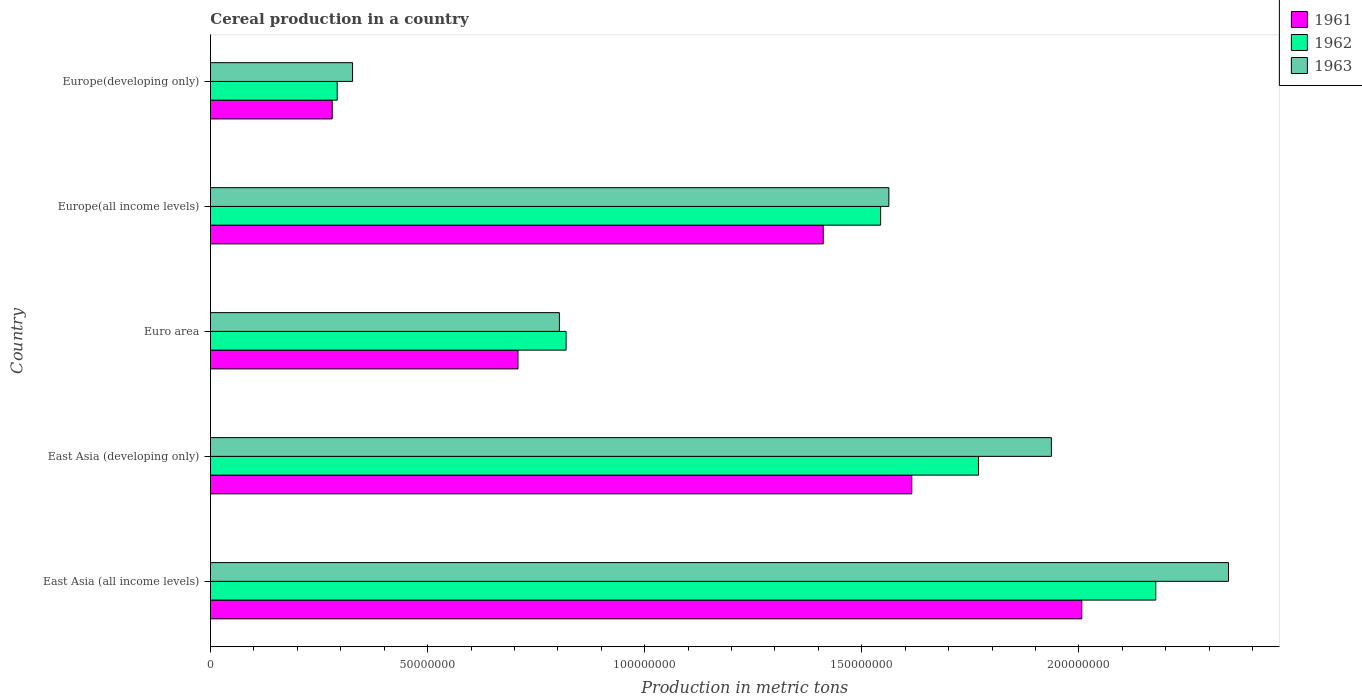How many different coloured bars are there?
Offer a very short reply. 3. How many groups of bars are there?
Keep it short and to the point. 5. Are the number of bars per tick equal to the number of legend labels?
Provide a succinct answer. Yes. Are the number of bars on each tick of the Y-axis equal?
Offer a very short reply. Yes. What is the label of the 1st group of bars from the top?
Provide a short and direct response. Europe(developing only). What is the total cereal production in 1962 in Europe(developing only)?
Keep it short and to the point. 2.92e+07. Across all countries, what is the maximum total cereal production in 1961?
Your answer should be very brief. 2.01e+08. Across all countries, what is the minimum total cereal production in 1961?
Your response must be concise. 2.80e+07. In which country was the total cereal production in 1962 maximum?
Make the answer very short. East Asia (all income levels). In which country was the total cereal production in 1962 minimum?
Give a very brief answer. Europe(developing only). What is the total total cereal production in 1963 in the graph?
Your response must be concise. 6.97e+08. What is the difference between the total cereal production in 1962 in East Asia (all income levels) and that in Europe(all income levels)?
Your answer should be compact. 6.34e+07. What is the difference between the total cereal production in 1961 in Europe(developing only) and the total cereal production in 1963 in East Asia (developing only)?
Ensure brevity in your answer.  -1.66e+08. What is the average total cereal production in 1962 per country?
Keep it short and to the point. 1.32e+08. What is the difference between the total cereal production in 1963 and total cereal production in 1961 in East Asia (developing only)?
Your response must be concise. 3.21e+07. In how many countries, is the total cereal production in 1963 greater than 210000000 metric tons?
Your response must be concise. 1. What is the ratio of the total cereal production in 1963 in East Asia (all income levels) to that in Euro area?
Your answer should be compact. 2.92. Is the total cereal production in 1961 in Europe(all income levels) less than that in Europe(developing only)?
Provide a short and direct response. No. Is the difference between the total cereal production in 1963 in East Asia (all income levels) and East Asia (developing only) greater than the difference between the total cereal production in 1961 in East Asia (all income levels) and East Asia (developing only)?
Keep it short and to the point. Yes. What is the difference between the highest and the second highest total cereal production in 1961?
Keep it short and to the point. 3.92e+07. What is the difference between the highest and the lowest total cereal production in 1963?
Make the answer very short. 2.02e+08. What does the 2nd bar from the top in Europe(developing only) represents?
Make the answer very short. 1962. Are all the bars in the graph horizontal?
Offer a very short reply. Yes. How many countries are there in the graph?
Offer a very short reply. 5. What is the difference between two consecutive major ticks on the X-axis?
Offer a very short reply. 5.00e+07. Are the values on the major ticks of X-axis written in scientific E-notation?
Give a very brief answer. No. Where does the legend appear in the graph?
Ensure brevity in your answer.  Top right. How are the legend labels stacked?
Ensure brevity in your answer.  Vertical. What is the title of the graph?
Offer a very short reply. Cereal production in a country. Does "2007" appear as one of the legend labels in the graph?
Your answer should be compact. No. What is the label or title of the X-axis?
Provide a succinct answer. Production in metric tons. What is the label or title of the Y-axis?
Give a very brief answer. Country. What is the Production in metric tons in 1961 in East Asia (all income levels)?
Provide a short and direct response. 2.01e+08. What is the Production in metric tons in 1962 in East Asia (all income levels)?
Ensure brevity in your answer.  2.18e+08. What is the Production in metric tons of 1963 in East Asia (all income levels)?
Keep it short and to the point. 2.34e+08. What is the Production in metric tons in 1961 in East Asia (developing only)?
Give a very brief answer. 1.62e+08. What is the Production in metric tons of 1962 in East Asia (developing only)?
Keep it short and to the point. 1.77e+08. What is the Production in metric tons of 1963 in East Asia (developing only)?
Make the answer very short. 1.94e+08. What is the Production in metric tons of 1961 in Euro area?
Ensure brevity in your answer.  7.08e+07. What is the Production in metric tons in 1962 in Euro area?
Provide a succinct answer. 8.19e+07. What is the Production in metric tons in 1963 in Euro area?
Your response must be concise. 8.04e+07. What is the Production in metric tons of 1961 in Europe(all income levels)?
Provide a succinct answer. 1.41e+08. What is the Production in metric tons of 1962 in Europe(all income levels)?
Your answer should be very brief. 1.54e+08. What is the Production in metric tons of 1963 in Europe(all income levels)?
Provide a succinct answer. 1.56e+08. What is the Production in metric tons in 1961 in Europe(developing only)?
Offer a terse response. 2.80e+07. What is the Production in metric tons of 1962 in Europe(developing only)?
Ensure brevity in your answer.  2.92e+07. What is the Production in metric tons in 1963 in Europe(developing only)?
Your response must be concise. 3.27e+07. Across all countries, what is the maximum Production in metric tons in 1961?
Give a very brief answer. 2.01e+08. Across all countries, what is the maximum Production in metric tons of 1962?
Provide a succinct answer. 2.18e+08. Across all countries, what is the maximum Production in metric tons in 1963?
Your response must be concise. 2.34e+08. Across all countries, what is the minimum Production in metric tons of 1961?
Your answer should be compact. 2.80e+07. Across all countries, what is the minimum Production in metric tons in 1962?
Make the answer very short. 2.92e+07. Across all countries, what is the minimum Production in metric tons in 1963?
Offer a very short reply. 3.27e+07. What is the total Production in metric tons of 1961 in the graph?
Make the answer very short. 6.02e+08. What is the total Production in metric tons in 1962 in the graph?
Your response must be concise. 6.60e+08. What is the total Production in metric tons in 1963 in the graph?
Offer a terse response. 6.97e+08. What is the difference between the Production in metric tons in 1961 in East Asia (all income levels) and that in East Asia (developing only)?
Ensure brevity in your answer.  3.92e+07. What is the difference between the Production in metric tons in 1962 in East Asia (all income levels) and that in East Asia (developing only)?
Keep it short and to the point. 4.08e+07. What is the difference between the Production in metric tons in 1963 in East Asia (all income levels) and that in East Asia (developing only)?
Ensure brevity in your answer.  4.08e+07. What is the difference between the Production in metric tons in 1961 in East Asia (all income levels) and that in Euro area?
Provide a succinct answer. 1.30e+08. What is the difference between the Production in metric tons of 1962 in East Asia (all income levels) and that in Euro area?
Your answer should be compact. 1.36e+08. What is the difference between the Production in metric tons in 1963 in East Asia (all income levels) and that in Euro area?
Your answer should be compact. 1.54e+08. What is the difference between the Production in metric tons of 1961 in East Asia (all income levels) and that in Europe(all income levels)?
Offer a terse response. 5.95e+07. What is the difference between the Production in metric tons in 1962 in East Asia (all income levels) and that in Europe(all income levels)?
Make the answer very short. 6.34e+07. What is the difference between the Production in metric tons of 1963 in East Asia (all income levels) and that in Europe(all income levels)?
Offer a very short reply. 7.82e+07. What is the difference between the Production in metric tons in 1961 in East Asia (all income levels) and that in Europe(developing only)?
Offer a very short reply. 1.73e+08. What is the difference between the Production in metric tons of 1962 in East Asia (all income levels) and that in Europe(developing only)?
Your answer should be compact. 1.89e+08. What is the difference between the Production in metric tons of 1963 in East Asia (all income levels) and that in Europe(developing only)?
Your response must be concise. 2.02e+08. What is the difference between the Production in metric tons of 1961 in East Asia (developing only) and that in Euro area?
Ensure brevity in your answer.  9.07e+07. What is the difference between the Production in metric tons in 1962 in East Asia (developing only) and that in Euro area?
Offer a very short reply. 9.50e+07. What is the difference between the Production in metric tons in 1963 in East Asia (developing only) and that in Euro area?
Offer a terse response. 1.13e+08. What is the difference between the Production in metric tons in 1961 in East Asia (developing only) and that in Europe(all income levels)?
Make the answer very short. 2.04e+07. What is the difference between the Production in metric tons of 1962 in East Asia (developing only) and that in Europe(all income levels)?
Offer a terse response. 2.26e+07. What is the difference between the Production in metric tons in 1963 in East Asia (developing only) and that in Europe(all income levels)?
Your response must be concise. 3.74e+07. What is the difference between the Production in metric tons in 1961 in East Asia (developing only) and that in Europe(developing only)?
Your answer should be compact. 1.33e+08. What is the difference between the Production in metric tons of 1962 in East Asia (developing only) and that in Europe(developing only)?
Your answer should be very brief. 1.48e+08. What is the difference between the Production in metric tons in 1963 in East Asia (developing only) and that in Europe(developing only)?
Provide a succinct answer. 1.61e+08. What is the difference between the Production in metric tons in 1961 in Euro area and that in Europe(all income levels)?
Provide a succinct answer. -7.03e+07. What is the difference between the Production in metric tons of 1962 in Euro area and that in Europe(all income levels)?
Give a very brief answer. -7.24e+07. What is the difference between the Production in metric tons of 1963 in Euro area and that in Europe(all income levels)?
Give a very brief answer. -7.59e+07. What is the difference between the Production in metric tons in 1961 in Euro area and that in Europe(developing only)?
Your response must be concise. 4.28e+07. What is the difference between the Production in metric tons of 1962 in Euro area and that in Europe(developing only)?
Your answer should be very brief. 5.27e+07. What is the difference between the Production in metric tons of 1963 in Euro area and that in Europe(developing only)?
Provide a succinct answer. 4.76e+07. What is the difference between the Production in metric tons in 1961 in Europe(all income levels) and that in Europe(developing only)?
Provide a succinct answer. 1.13e+08. What is the difference between the Production in metric tons in 1962 in Europe(all income levels) and that in Europe(developing only)?
Make the answer very short. 1.25e+08. What is the difference between the Production in metric tons in 1963 in Europe(all income levels) and that in Europe(developing only)?
Your answer should be compact. 1.24e+08. What is the difference between the Production in metric tons of 1961 in East Asia (all income levels) and the Production in metric tons of 1962 in East Asia (developing only)?
Your response must be concise. 2.38e+07. What is the difference between the Production in metric tons of 1961 in East Asia (all income levels) and the Production in metric tons of 1963 in East Asia (developing only)?
Your answer should be very brief. 7.01e+06. What is the difference between the Production in metric tons in 1962 in East Asia (all income levels) and the Production in metric tons in 1963 in East Asia (developing only)?
Offer a terse response. 2.40e+07. What is the difference between the Production in metric tons in 1961 in East Asia (all income levels) and the Production in metric tons in 1962 in Euro area?
Your answer should be compact. 1.19e+08. What is the difference between the Production in metric tons of 1961 in East Asia (all income levels) and the Production in metric tons of 1963 in Euro area?
Keep it short and to the point. 1.20e+08. What is the difference between the Production in metric tons of 1962 in East Asia (all income levels) and the Production in metric tons of 1963 in Euro area?
Your answer should be compact. 1.37e+08. What is the difference between the Production in metric tons of 1961 in East Asia (all income levels) and the Production in metric tons of 1962 in Europe(all income levels)?
Make the answer very short. 4.63e+07. What is the difference between the Production in metric tons in 1961 in East Asia (all income levels) and the Production in metric tons in 1963 in Europe(all income levels)?
Make the answer very short. 4.44e+07. What is the difference between the Production in metric tons in 1962 in East Asia (all income levels) and the Production in metric tons in 1963 in Europe(all income levels)?
Give a very brief answer. 6.15e+07. What is the difference between the Production in metric tons of 1961 in East Asia (all income levels) and the Production in metric tons of 1962 in Europe(developing only)?
Offer a very short reply. 1.71e+08. What is the difference between the Production in metric tons of 1961 in East Asia (all income levels) and the Production in metric tons of 1963 in Europe(developing only)?
Give a very brief answer. 1.68e+08. What is the difference between the Production in metric tons in 1962 in East Asia (all income levels) and the Production in metric tons in 1963 in Europe(developing only)?
Provide a succinct answer. 1.85e+08. What is the difference between the Production in metric tons in 1961 in East Asia (developing only) and the Production in metric tons in 1962 in Euro area?
Offer a terse response. 7.96e+07. What is the difference between the Production in metric tons in 1961 in East Asia (developing only) and the Production in metric tons in 1963 in Euro area?
Keep it short and to the point. 8.12e+07. What is the difference between the Production in metric tons of 1962 in East Asia (developing only) and the Production in metric tons of 1963 in Euro area?
Your response must be concise. 9.65e+07. What is the difference between the Production in metric tons of 1961 in East Asia (developing only) and the Production in metric tons of 1962 in Europe(all income levels)?
Ensure brevity in your answer.  7.18e+06. What is the difference between the Production in metric tons in 1961 in East Asia (developing only) and the Production in metric tons in 1963 in Europe(all income levels)?
Provide a succinct answer. 5.28e+06. What is the difference between the Production in metric tons of 1962 in East Asia (developing only) and the Production in metric tons of 1963 in Europe(all income levels)?
Your response must be concise. 2.07e+07. What is the difference between the Production in metric tons of 1961 in East Asia (developing only) and the Production in metric tons of 1962 in Europe(developing only)?
Provide a succinct answer. 1.32e+08. What is the difference between the Production in metric tons of 1961 in East Asia (developing only) and the Production in metric tons of 1963 in Europe(developing only)?
Make the answer very short. 1.29e+08. What is the difference between the Production in metric tons of 1962 in East Asia (developing only) and the Production in metric tons of 1963 in Europe(developing only)?
Your response must be concise. 1.44e+08. What is the difference between the Production in metric tons of 1961 in Euro area and the Production in metric tons of 1962 in Europe(all income levels)?
Your answer should be very brief. -8.35e+07. What is the difference between the Production in metric tons of 1961 in Euro area and the Production in metric tons of 1963 in Europe(all income levels)?
Ensure brevity in your answer.  -8.54e+07. What is the difference between the Production in metric tons in 1962 in Euro area and the Production in metric tons in 1963 in Europe(all income levels)?
Provide a short and direct response. -7.43e+07. What is the difference between the Production in metric tons in 1961 in Euro area and the Production in metric tons in 1962 in Europe(developing only)?
Your answer should be compact. 4.16e+07. What is the difference between the Production in metric tons in 1961 in Euro area and the Production in metric tons in 1963 in Europe(developing only)?
Offer a very short reply. 3.81e+07. What is the difference between the Production in metric tons in 1962 in Euro area and the Production in metric tons in 1963 in Europe(developing only)?
Ensure brevity in your answer.  4.92e+07. What is the difference between the Production in metric tons of 1961 in Europe(all income levels) and the Production in metric tons of 1962 in Europe(developing only)?
Offer a terse response. 1.12e+08. What is the difference between the Production in metric tons in 1961 in Europe(all income levels) and the Production in metric tons in 1963 in Europe(developing only)?
Your answer should be compact. 1.08e+08. What is the difference between the Production in metric tons of 1962 in Europe(all income levels) and the Production in metric tons of 1963 in Europe(developing only)?
Your answer should be very brief. 1.22e+08. What is the average Production in metric tons of 1961 per country?
Provide a short and direct response. 1.20e+08. What is the average Production in metric tons of 1962 per country?
Ensure brevity in your answer.  1.32e+08. What is the average Production in metric tons of 1963 per country?
Offer a very short reply. 1.39e+08. What is the difference between the Production in metric tons in 1961 and Production in metric tons in 1962 in East Asia (all income levels)?
Provide a short and direct response. -1.70e+07. What is the difference between the Production in metric tons in 1961 and Production in metric tons in 1963 in East Asia (all income levels)?
Make the answer very short. -3.38e+07. What is the difference between the Production in metric tons in 1962 and Production in metric tons in 1963 in East Asia (all income levels)?
Ensure brevity in your answer.  -1.67e+07. What is the difference between the Production in metric tons of 1961 and Production in metric tons of 1962 in East Asia (developing only)?
Give a very brief answer. -1.54e+07. What is the difference between the Production in metric tons in 1961 and Production in metric tons in 1963 in East Asia (developing only)?
Make the answer very short. -3.21e+07. What is the difference between the Production in metric tons of 1962 and Production in metric tons of 1963 in East Asia (developing only)?
Ensure brevity in your answer.  -1.68e+07. What is the difference between the Production in metric tons of 1961 and Production in metric tons of 1962 in Euro area?
Keep it short and to the point. -1.11e+07. What is the difference between the Production in metric tons in 1961 and Production in metric tons in 1963 in Euro area?
Ensure brevity in your answer.  -9.54e+06. What is the difference between the Production in metric tons in 1962 and Production in metric tons in 1963 in Euro area?
Ensure brevity in your answer.  1.54e+06. What is the difference between the Production in metric tons in 1961 and Production in metric tons in 1962 in Europe(all income levels)?
Make the answer very short. -1.32e+07. What is the difference between the Production in metric tons in 1961 and Production in metric tons in 1963 in Europe(all income levels)?
Make the answer very short. -1.51e+07. What is the difference between the Production in metric tons in 1962 and Production in metric tons in 1963 in Europe(all income levels)?
Your response must be concise. -1.90e+06. What is the difference between the Production in metric tons of 1961 and Production in metric tons of 1962 in Europe(developing only)?
Provide a short and direct response. -1.15e+06. What is the difference between the Production in metric tons of 1961 and Production in metric tons of 1963 in Europe(developing only)?
Provide a short and direct response. -4.68e+06. What is the difference between the Production in metric tons of 1962 and Production in metric tons of 1963 in Europe(developing only)?
Your response must be concise. -3.54e+06. What is the ratio of the Production in metric tons of 1961 in East Asia (all income levels) to that in East Asia (developing only)?
Make the answer very short. 1.24. What is the ratio of the Production in metric tons in 1962 in East Asia (all income levels) to that in East Asia (developing only)?
Ensure brevity in your answer.  1.23. What is the ratio of the Production in metric tons in 1963 in East Asia (all income levels) to that in East Asia (developing only)?
Keep it short and to the point. 1.21. What is the ratio of the Production in metric tons in 1961 in East Asia (all income levels) to that in Euro area?
Your answer should be very brief. 2.83. What is the ratio of the Production in metric tons of 1962 in East Asia (all income levels) to that in Euro area?
Offer a very short reply. 2.66. What is the ratio of the Production in metric tons in 1963 in East Asia (all income levels) to that in Euro area?
Offer a terse response. 2.92. What is the ratio of the Production in metric tons of 1961 in East Asia (all income levels) to that in Europe(all income levels)?
Give a very brief answer. 1.42. What is the ratio of the Production in metric tons of 1962 in East Asia (all income levels) to that in Europe(all income levels)?
Your response must be concise. 1.41. What is the ratio of the Production in metric tons of 1963 in East Asia (all income levels) to that in Europe(all income levels)?
Make the answer very short. 1.5. What is the ratio of the Production in metric tons of 1961 in East Asia (all income levels) to that in Europe(developing only)?
Ensure brevity in your answer.  7.16. What is the ratio of the Production in metric tons of 1962 in East Asia (all income levels) to that in Europe(developing only)?
Offer a very short reply. 7.46. What is the ratio of the Production in metric tons of 1963 in East Asia (all income levels) to that in Europe(developing only)?
Your response must be concise. 7.16. What is the ratio of the Production in metric tons in 1961 in East Asia (developing only) to that in Euro area?
Your response must be concise. 2.28. What is the ratio of the Production in metric tons of 1962 in East Asia (developing only) to that in Euro area?
Give a very brief answer. 2.16. What is the ratio of the Production in metric tons of 1963 in East Asia (developing only) to that in Euro area?
Offer a very short reply. 2.41. What is the ratio of the Production in metric tons of 1961 in East Asia (developing only) to that in Europe(all income levels)?
Your answer should be very brief. 1.14. What is the ratio of the Production in metric tons of 1962 in East Asia (developing only) to that in Europe(all income levels)?
Offer a very short reply. 1.15. What is the ratio of the Production in metric tons of 1963 in East Asia (developing only) to that in Europe(all income levels)?
Provide a succinct answer. 1.24. What is the ratio of the Production in metric tons in 1961 in East Asia (developing only) to that in Europe(developing only)?
Offer a very short reply. 5.76. What is the ratio of the Production in metric tons in 1962 in East Asia (developing only) to that in Europe(developing only)?
Make the answer very short. 6.06. What is the ratio of the Production in metric tons in 1963 in East Asia (developing only) to that in Europe(developing only)?
Provide a short and direct response. 5.92. What is the ratio of the Production in metric tons of 1961 in Euro area to that in Europe(all income levels)?
Provide a short and direct response. 0.5. What is the ratio of the Production in metric tons in 1962 in Euro area to that in Europe(all income levels)?
Offer a very short reply. 0.53. What is the ratio of the Production in metric tons in 1963 in Euro area to that in Europe(all income levels)?
Your answer should be compact. 0.51. What is the ratio of the Production in metric tons of 1961 in Euro area to that in Europe(developing only)?
Make the answer very short. 2.53. What is the ratio of the Production in metric tons in 1962 in Euro area to that in Europe(developing only)?
Provide a short and direct response. 2.81. What is the ratio of the Production in metric tons in 1963 in Euro area to that in Europe(developing only)?
Your answer should be compact. 2.46. What is the ratio of the Production in metric tons in 1961 in Europe(all income levels) to that in Europe(developing only)?
Give a very brief answer. 5.03. What is the ratio of the Production in metric tons in 1962 in Europe(all income levels) to that in Europe(developing only)?
Provide a short and direct response. 5.29. What is the ratio of the Production in metric tons of 1963 in Europe(all income levels) to that in Europe(developing only)?
Make the answer very short. 4.77. What is the difference between the highest and the second highest Production in metric tons of 1961?
Give a very brief answer. 3.92e+07. What is the difference between the highest and the second highest Production in metric tons in 1962?
Your answer should be very brief. 4.08e+07. What is the difference between the highest and the second highest Production in metric tons in 1963?
Give a very brief answer. 4.08e+07. What is the difference between the highest and the lowest Production in metric tons of 1961?
Give a very brief answer. 1.73e+08. What is the difference between the highest and the lowest Production in metric tons in 1962?
Your answer should be compact. 1.89e+08. What is the difference between the highest and the lowest Production in metric tons of 1963?
Provide a succinct answer. 2.02e+08. 